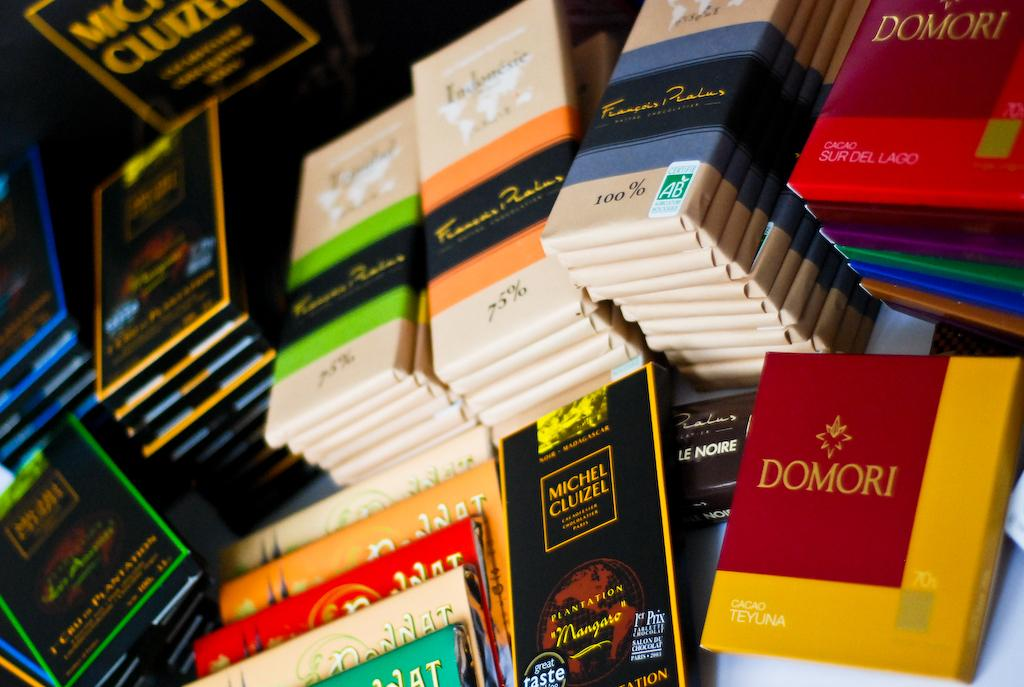<image>
Provide a brief description of the given image. A pile of colorfully wrapped cacao products displaying percentages such as 75, or 100. 